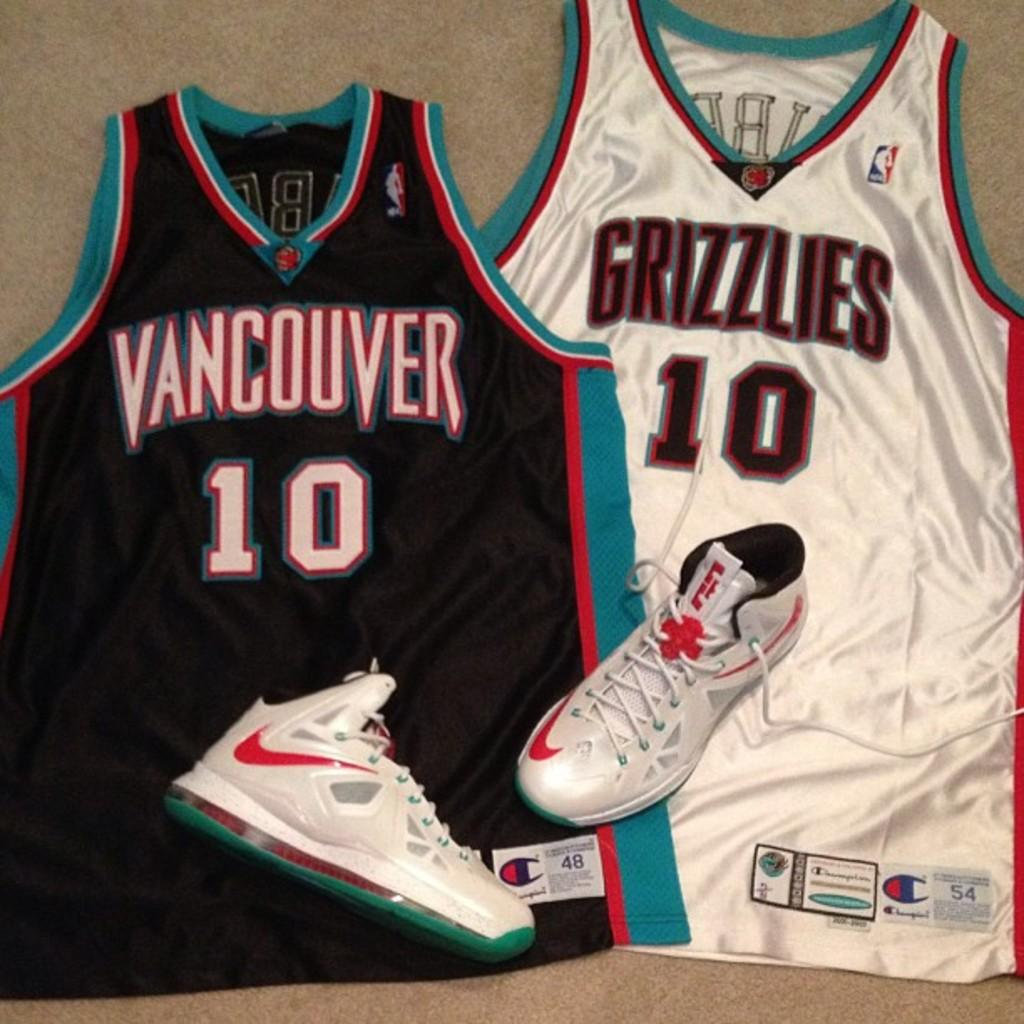<image>
Share a concise interpretation of the image provided. Two Vancouver Grizzles jerseys number 10 with a pair of Nike shoes on top 